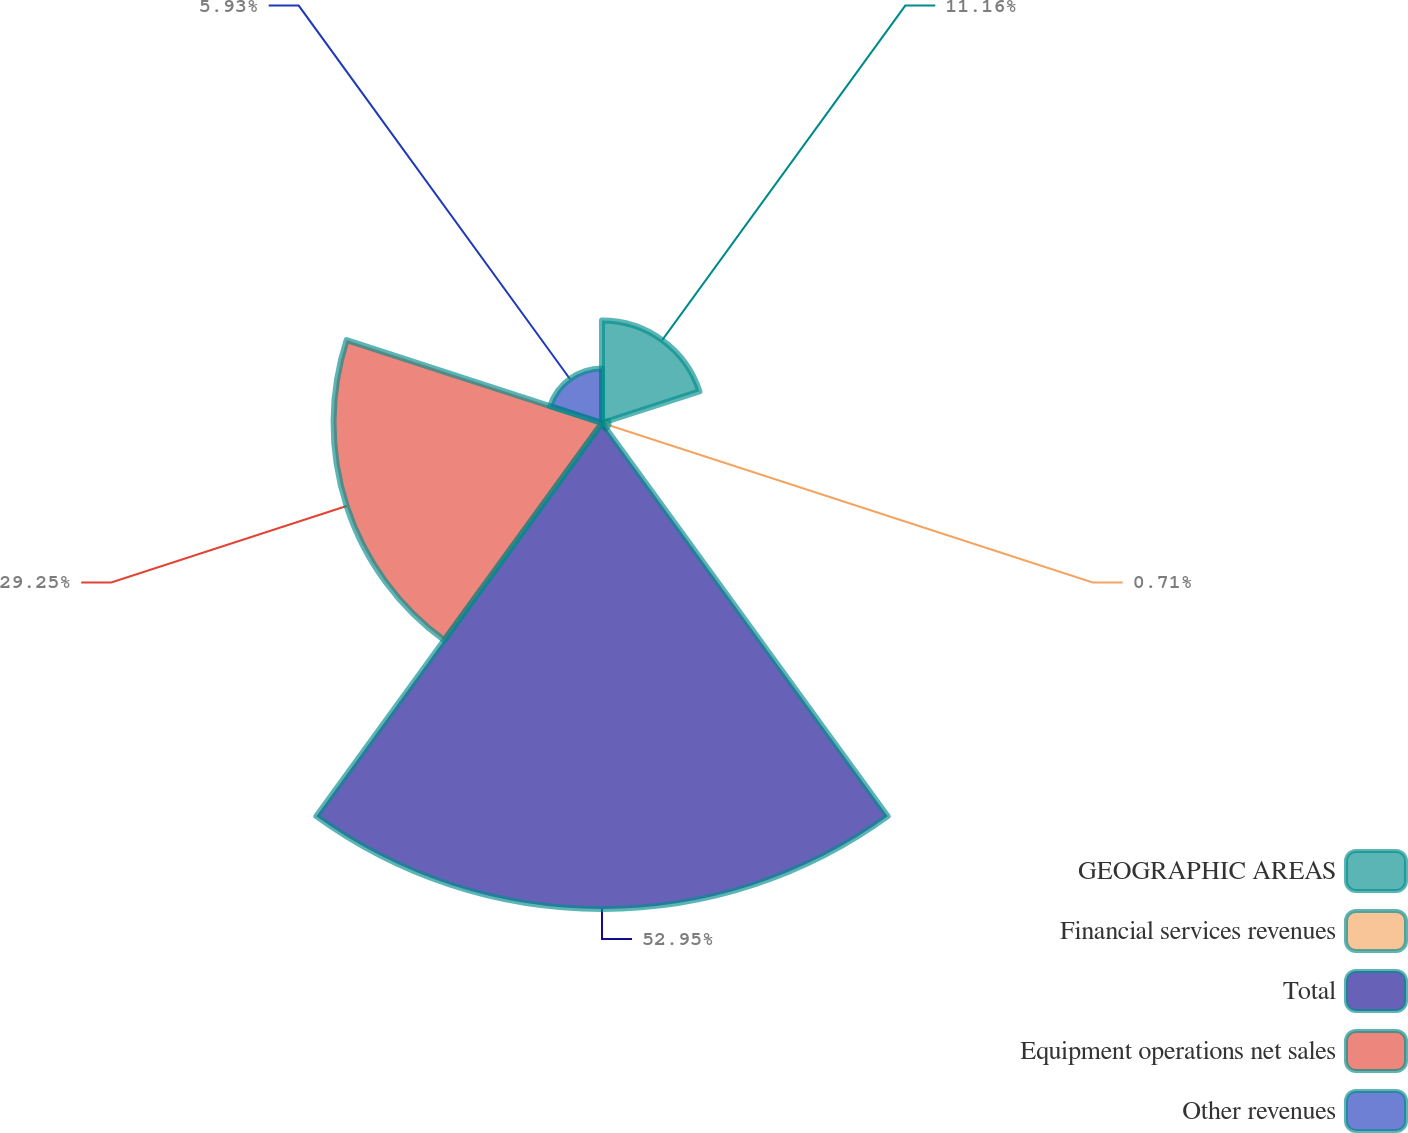Convert chart to OTSL. <chart><loc_0><loc_0><loc_500><loc_500><pie_chart><fcel>GEOGRAPHIC AREAS<fcel>Financial services revenues<fcel>Total<fcel>Equipment operations net sales<fcel>Other revenues<nl><fcel>11.16%<fcel>0.71%<fcel>52.95%<fcel>29.25%<fcel>5.93%<nl></chart> 